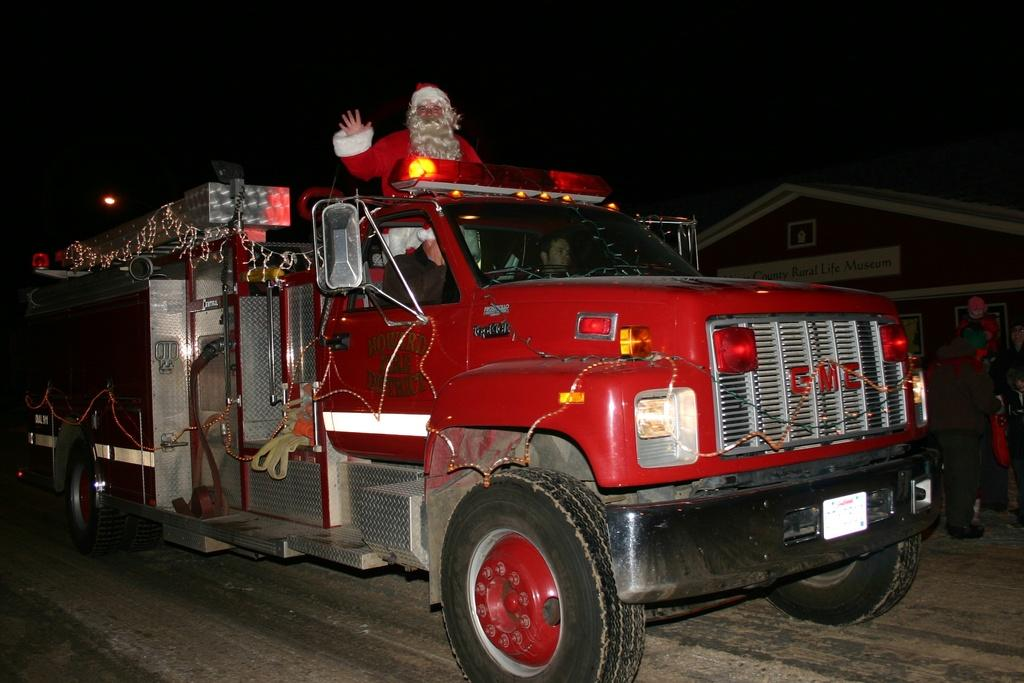What is the main subject in the foreground of the image? There is a truck in the foreground of the image. What is the truck doing in the image? The truck is moving on the road. Can you describe the person on the truck? There is a person standing on the truck. What can be seen in the background of the image? There is a building and a light in the background of the image. What type of spoon is being used by the duck in the image? There is no duck or spoon present in the image. 